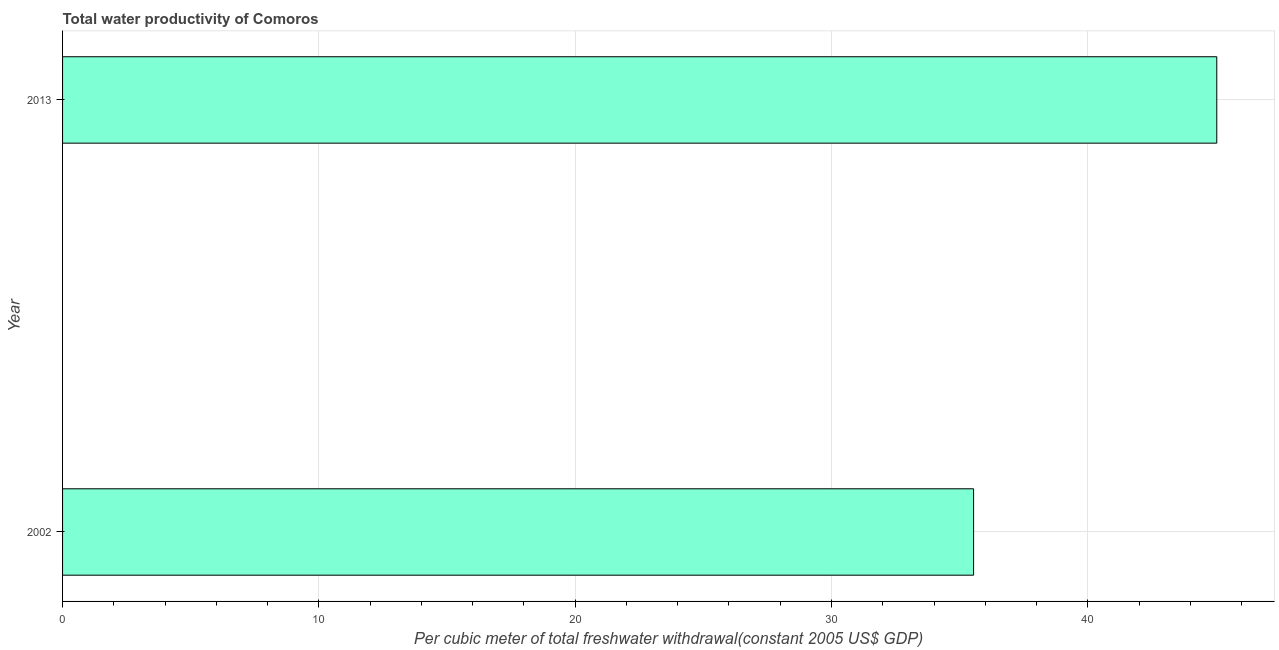What is the title of the graph?
Your answer should be compact. Total water productivity of Comoros. What is the label or title of the X-axis?
Provide a succinct answer. Per cubic meter of total freshwater withdrawal(constant 2005 US$ GDP). What is the label or title of the Y-axis?
Provide a short and direct response. Year. What is the total water productivity in 2002?
Provide a succinct answer. 35.54. Across all years, what is the maximum total water productivity?
Offer a terse response. 45.03. Across all years, what is the minimum total water productivity?
Provide a short and direct response. 35.54. What is the sum of the total water productivity?
Your answer should be compact. 80.57. What is the difference between the total water productivity in 2002 and 2013?
Make the answer very short. -9.49. What is the average total water productivity per year?
Provide a short and direct response. 40.29. What is the median total water productivity?
Your answer should be very brief. 40.29. In how many years, is the total water productivity greater than 6 US$?
Your answer should be compact. 2. What is the ratio of the total water productivity in 2002 to that in 2013?
Offer a terse response. 0.79. How many bars are there?
Provide a succinct answer. 2. Are all the bars in the graph horizontal?
Offer a very short reply. Yes. How many years are there in the graph?
Offer a very short reply. 2. What is the difference between two consecutive major ticks on the X-axis?
Provide a succinct answer. 10. What is the Per cubic meter of total freshwater withdrawal(constant 2005 US$ GDP) in 2002?
Offer a very short reply. 35.54. What is the Per cubic meter of total freshwater withdrawal(constant 2005 US$ GDP) of 2013?
Your answer should be very brief. 45.03. What is the difference between the Per cubic meter of total freshwater withdrawal(constant 2005 US$ GDP) in 2002 and 2013?
Make the answer very short. -9.49. What is the ratio of the Per cubic meter of total freshwater withdrawal(constant 2005 US$ GDP) in 2002 to that in 2013?
Offer a terse response. 0.79. 